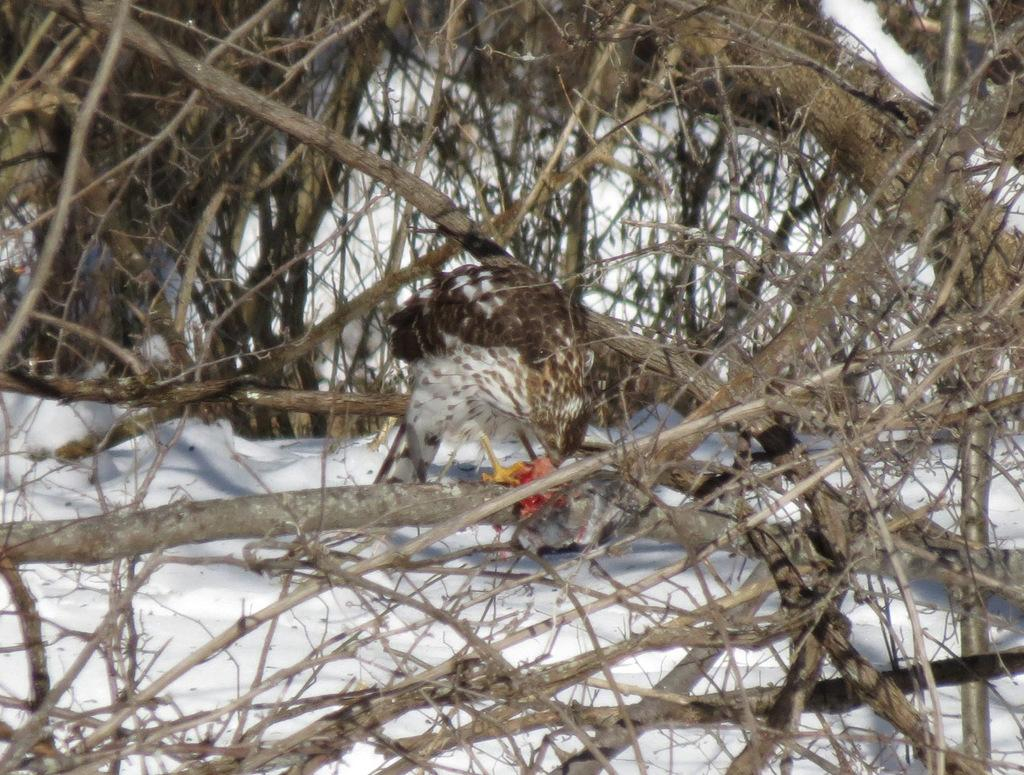What type of animal can be seen in the image? There is an animal on a tree branch in the image. What is the setting of the image? There is snow visible in the image, suggesting a winter or cold environment. What is the relation between the animal and the band in the image? There is no band present in the image, so it is not possible to determine any relation between the animal and a band. 